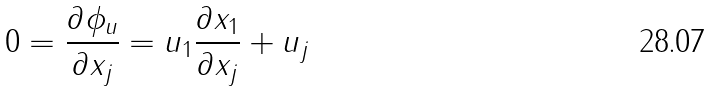<formula> <loc_0><loc_0><loc_500><loc_500>0 = \frac { \partial \phi _ { u } } { \partial x _ { j } } = u _ { 1 } \frac { \partial x _ { 1 } } { \partial x _ { j } } + u _ { j }</formula> 